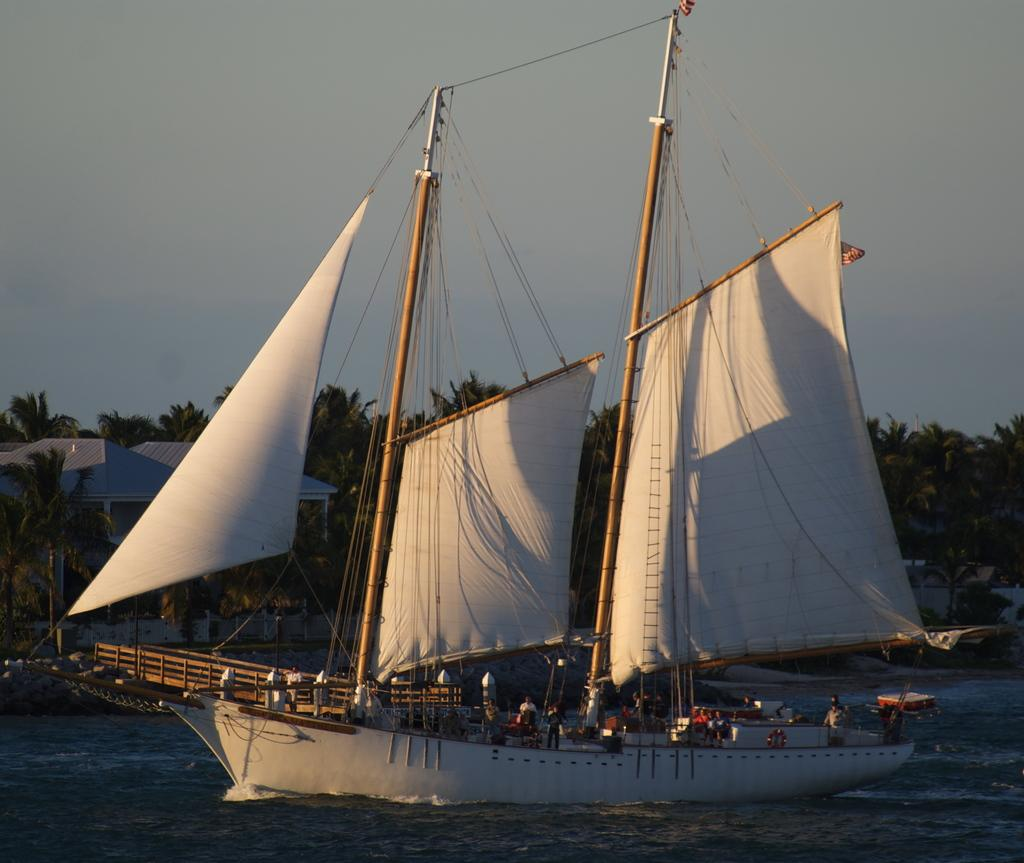What is in the water in the image? There is a boat in the water in the image. Who or what is inside the boat? There are people standing in the boat. What structures can be seen in the image? There are shelters visible in the image. What type of vegetation is visible in the background? There are trees in the background. How would you describe the sky in the image? The sky is cloudy in the image. What type of nut is being used as a step to enter the boat in the image? There is no nut being used as a step to enter the boat in the image. 